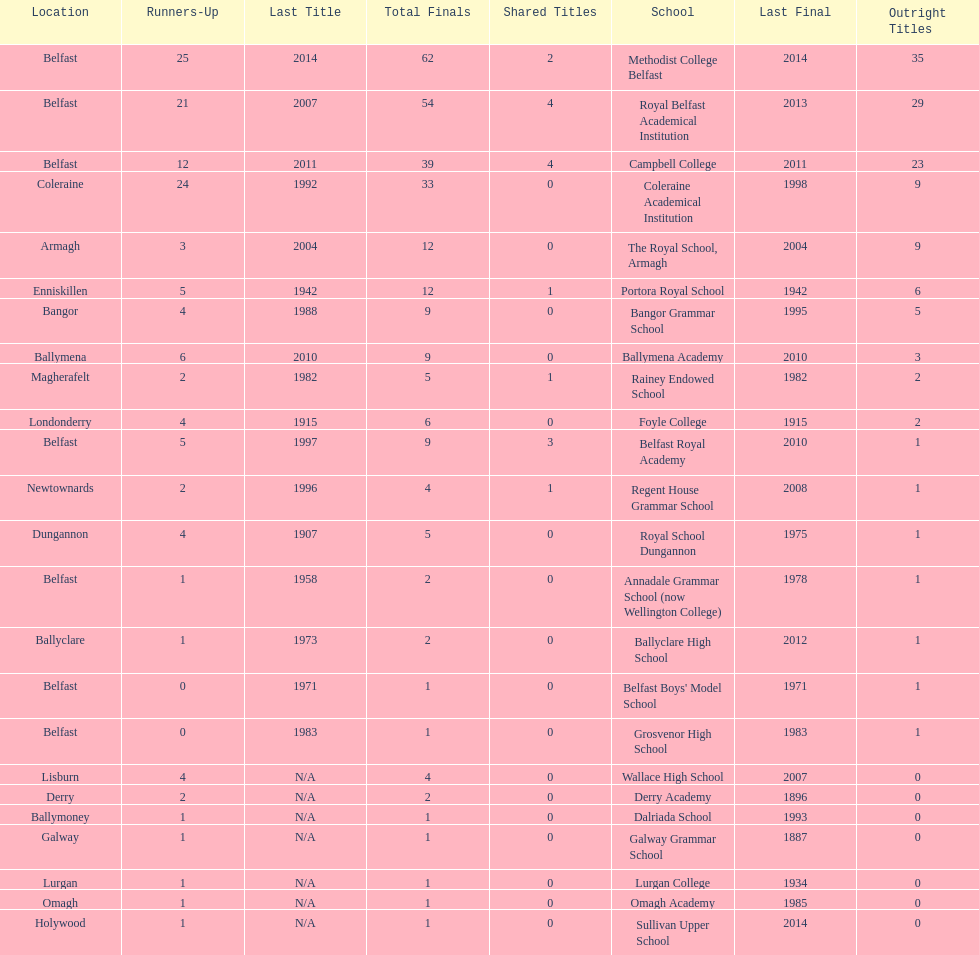What was the last year that the regent house grammar school won a title? 1996. 